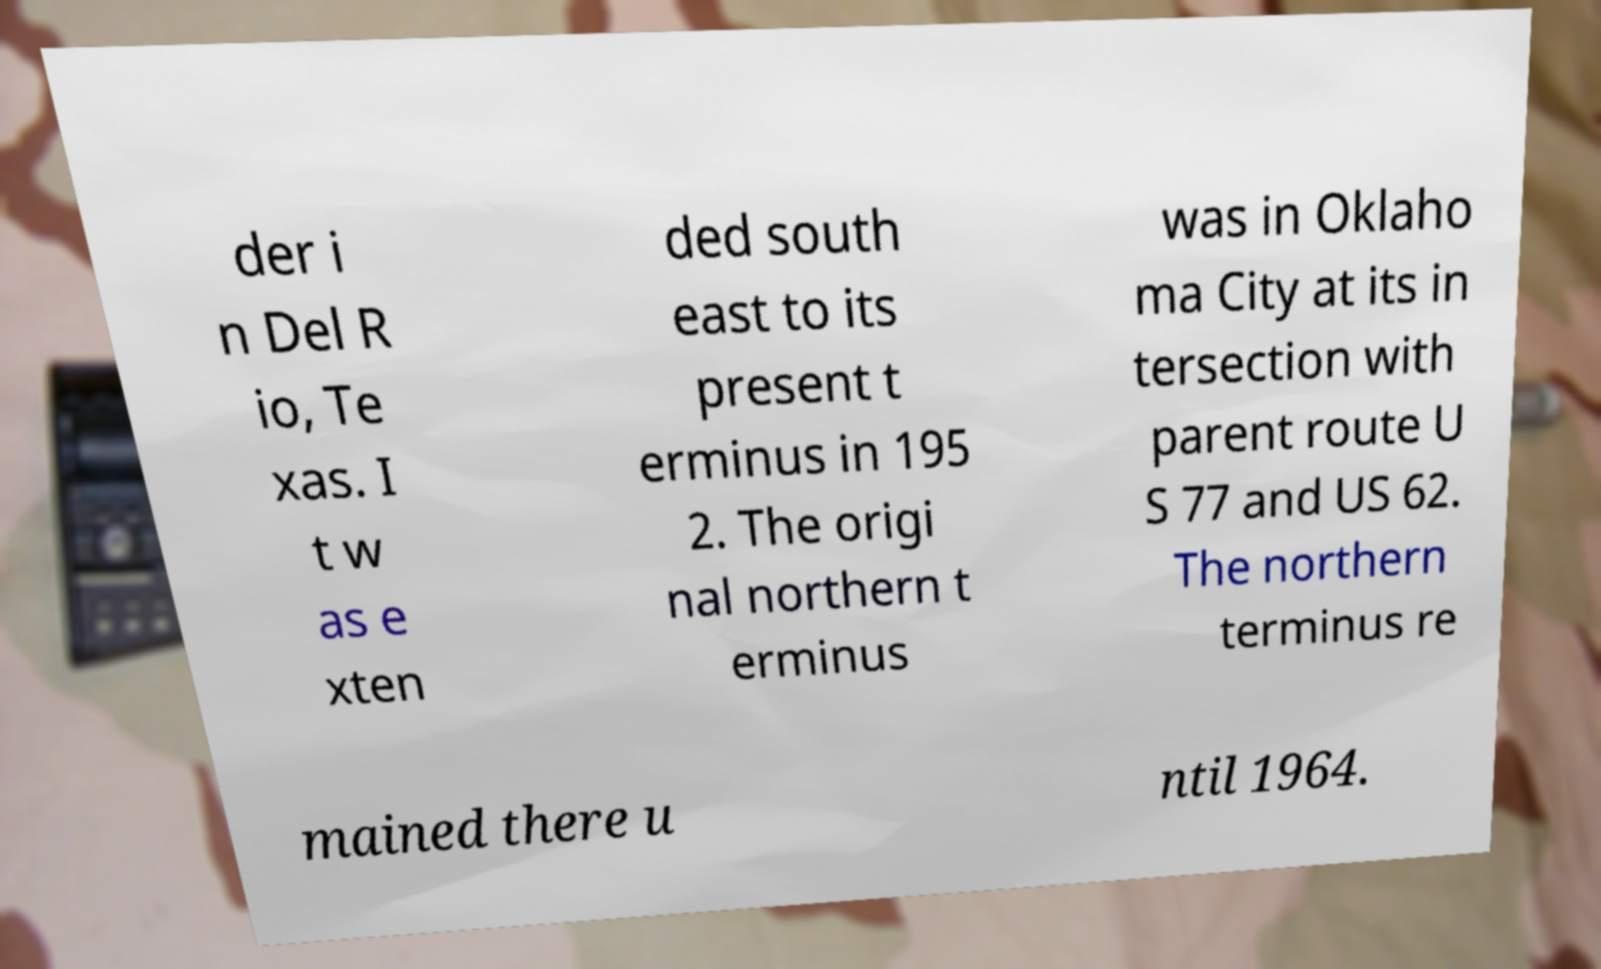For documentation purposes, I need the text within this image transcribed. Could you provide that? der i n Del R io, Te xas. I t w as e xten ded south east to its present t erminus in 195 2. The origi nal northern t erminus was in Oklaho ma City at its in tersection with parent route U S 77 and US 62. The northern terminus re mained there u ntil 1964. 